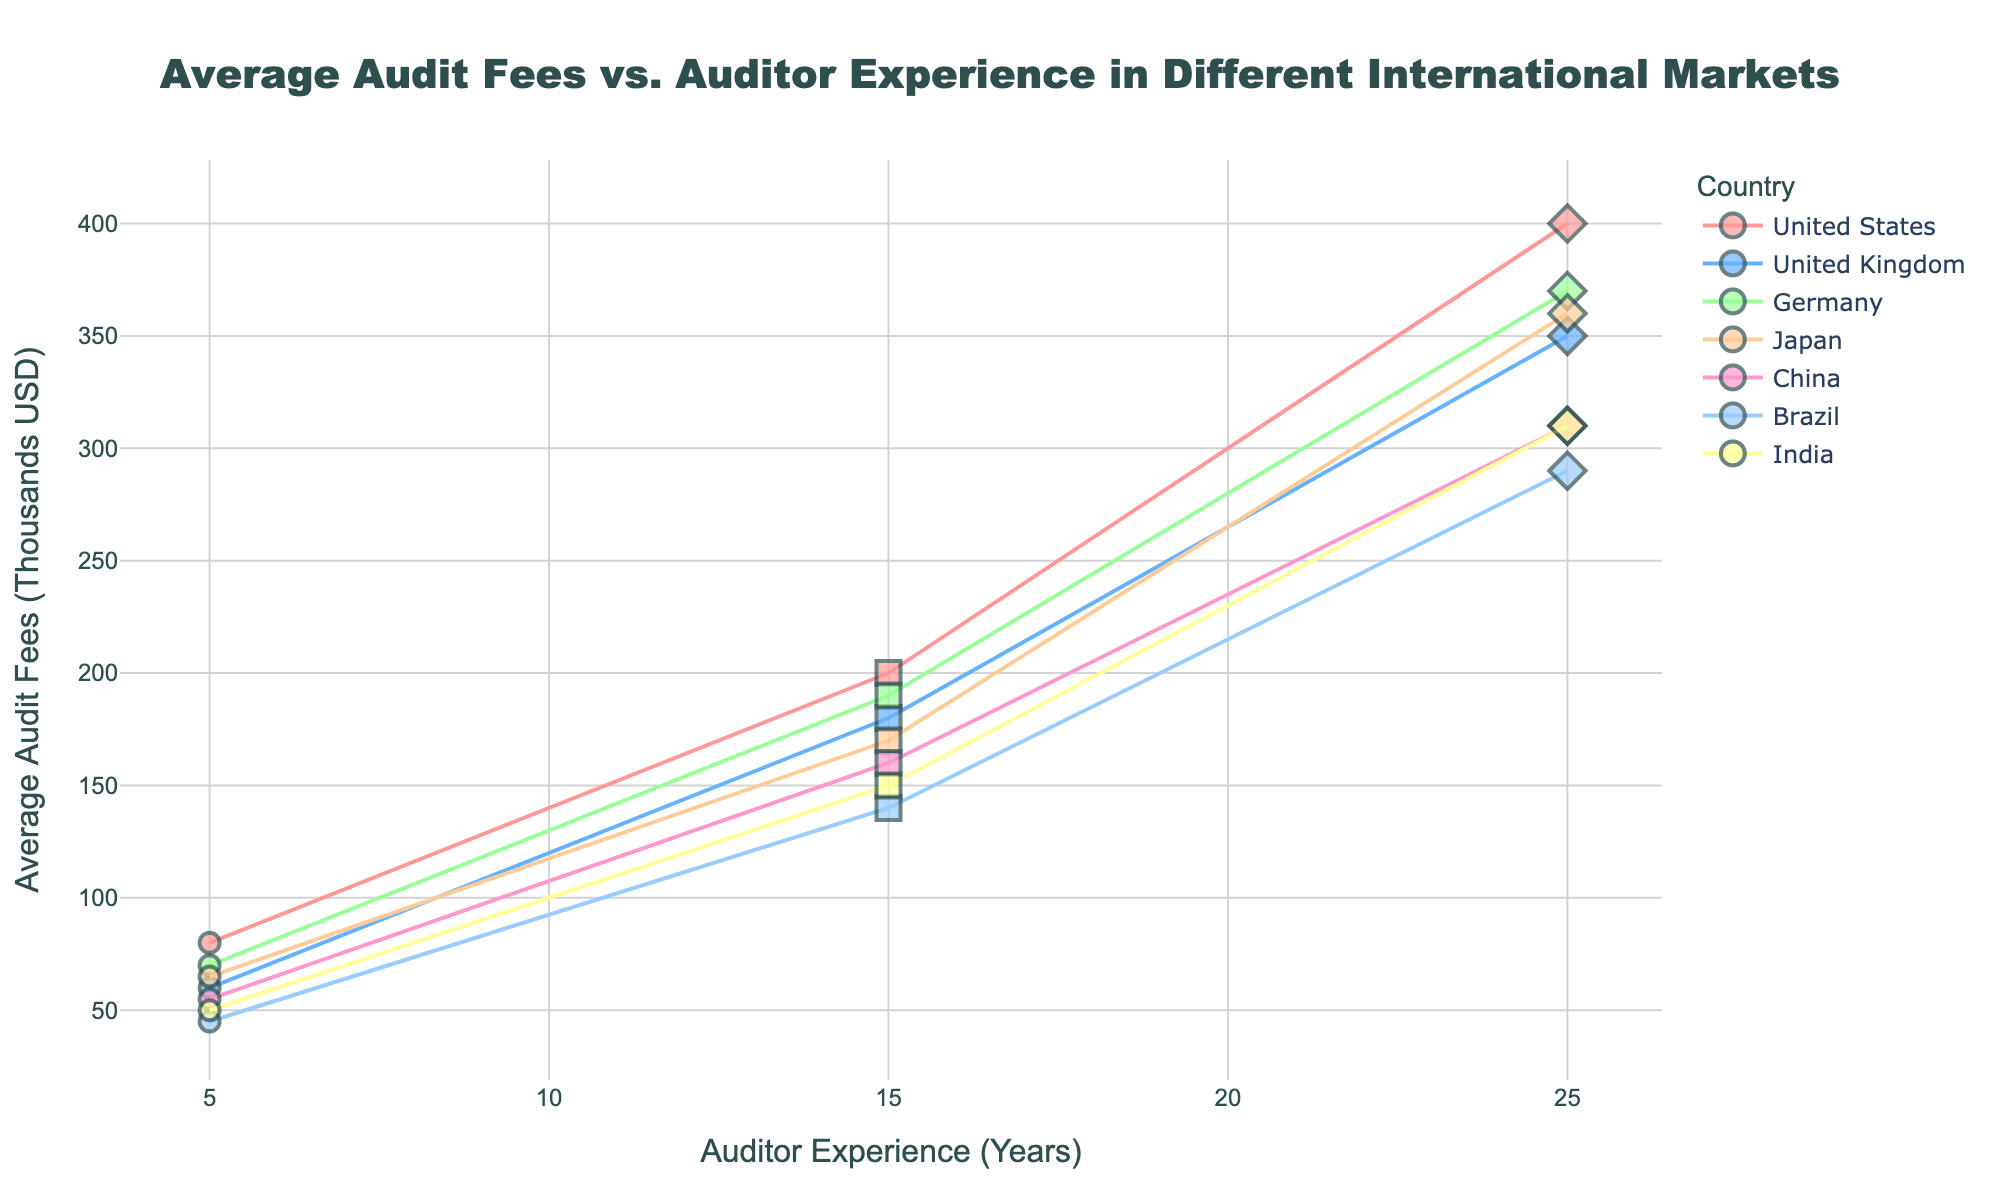What is the title of the plot? The title is typically placed at the top of the plot. Reading it directly gives us "Average Audit Fees vs. Auditor Experience in Different International Markets".
Answer: Average Audit Fees vs. Auditor Experience in Different International Markets Which country has the highest average audit fees for auditors with 5 years of experience? Locate the data points for 5 years' experience on the x-axis and check for the highest y-axis value. The highest here is the United States with $80,000.
Answer: United States How does the average audit fee change for auditors with 15 years of experience compared to 5 years of experience in Japan? Look at Japan's data points on the plot for 5 and 15 years' experience. The fees go from $65,000 to $170,000. Calculate the difference: $170,000 - $65,000 = $105,000.
Answer: The fees increase by $105,000 Which country shows the smallest increase in average audit fees from 5 to 25 years of experience? Review the lines connecting the data points for 5 and 25 years' experience in all countries. The smallest difference is seen in Brazil, which goes from $45,000 to $290,000.
Answer: Brazil In which country does the average audit fee reach $200,000 when auditors have 15 years of experience? Check all the points at 15 years of experience level to find where fees are $200,000. It is the United States.
Answer: United States Which company in Germany has the highest average audit fees? Hover over data points to see the company names. The highest fee for Germany is $370,000 associated with Allianz.
Answer: Allianz Compare the range of audit fees for the United Kingdom and China. Which country has a wider range? The range is calculated as the difference between the highest and lowest fees. For the UK: $350,000 - $60,000 = $290,000. For China: $310,000 - $55,000 = $255,000. The UK has a wider range.
Answer: United Kingdom Identify the trend in average audit fees with increasing auditor experience in India. Observe the data points for India. The fees increase incrementally as the experience goes from 5 to 25 years.
Answer: Increasing trend How many countries have an average audit fee above $300,000 for auditors with 25 years of experience? Count the countries where the 25 years' experience data point is above $300,000. These are the United States, Germany, Japan, China, and India; making a total of 5 countries.
Answer: Five countries Which company has the lowest average audit fee with 5 years of auditor experience? Hover over all 5-year experience data points to check for the lowest fee, which is Petróleo Brasileiro in Brazil with $45,000.
Answer: Petróleo Brasileiro 